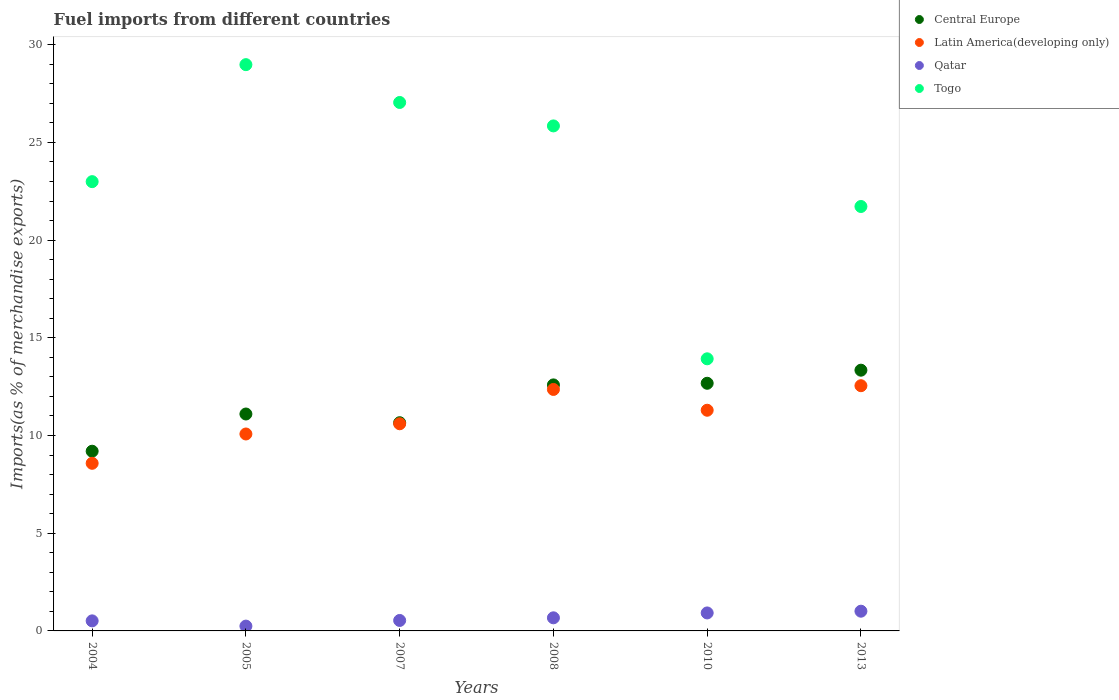How many different coloured dotlines are there?
Your answer should be very brief. 4. Is the number of dotlines equal to the number of legend labels?
Provide a succinct answer. Yes. What is the percentage of imports to different countries in Qatar in 2008?
Ensure brevity in your answer.  0.67. Across all years, what is the maximum percentage of imports to different countries in Qatar?
Make the answer very short. 1.01. Across all years, what is the minimum percentage of imports to different countries in Central Europe?
Provide a short and direct response. 9.2. In which year was the percentage of imports to different countries in Central Europe maximum?
Your answer should be very brief. 2013. What is the total percentage of imports to different countries in Togo in the graph?
Provide a succinct answer. 140.51. What is the difference between the percentage of imports to different countries in Central Europe in 2008 and that in 2013?
Your response must be concise. -0.75. What is the difference between the percentage of imports to different countries in Qatar in 2004 and the percentage of imports to different countries in Latin America(developing only) in 2008?
Give a very brief answer. -11.84. What is the average percentage of imports to different countries in Qatar per year?
Make the answer very short. 0.65. In the year 2010, what is the difference between the percentage of imports to different countries in Qatar and percentage of imports to different countries in Togo?
Provide a succinct answer. -13.01. In how many years, is the percentage of imports to different countries in Central Europe greater than 25 %?
Keep it short and to the point. 0. What is the ratio of the percentage of imports to different countries in Qatar in 2004 to that in 2013?
Keep it short and to the point. 0.51. Is the difference between the percentage of imports to different countries in Qatar in 2004 and 2013 greater than the difference between the percentage of imports to different countries in Togo in 2004 and 2013?
Provide a succinct answer. No. What is the difference between the highest and the second highest percentage of imports to different countries in Central Europe?
Provide a short and direct response. 0.67. What is the difference between the highest and the lowest percentage of imports to different countries in Togo?
Ensure brevity in your answer.  15.05. Is the sum of the percentage of imports to different countries in Togo in 2004 and 2007 greater than the maximum percentage of imports to different countries in Central Europe across all years?
Give a very brief answer. Yes. Is it the case that in every year, the sum of the percentage of imports to different countries in Central Europe and percentage of imports to different countries in Latin America(developing only)  is greater than the percentage of imports to different countries in Togo?
Ensure brevity in your answer.  No. Does the percentage of imports to different countries in Latin America(developing only) monotonically increase over the years?
Make the answer very short. No. Is the percentage of imports to different countries in Togo strictly greater than the percentage of imports to different countries in Latin America(developing only) over the years?
Ensure brevity in your answer.  Yes. Is the percentage of imports to different countries in Qatar strictly less than the percentage of imports to different countries in Latin America(developing only) over the years?
Your answer should be very brief. Yes. How many years are there in the graph?
Offer a very short reply. 6. What is the difference between two consecutive major ticks on the Y-axis?
Offer a terse response. 5. Does the graph contain grids?
Give a very brief answer. No. How many legend labels are there?
Provide a succinct answer. 4. What is the title of the graph?
Keep it short and to the point. Fuel imports from different countries. Does "Macao" appear as one of the legend labels in the graph?
Your answer should be compact. No. What is the label or title of the Y-axis?
Make the answer very short. Imports(as % of merchandise exports). What is the Imports(as % of merchandise exports) in Central Europe in 2004?
Offer a terse response. 9.2. What is the Imports(as % of merchandise exports) of Latin America(developing only) in 2004?
Your response must be concise. 8.58. What is the Imports(as % of merchandise exports) of Qatar in 2004?
Ensure brevity in your answer.  0.51. What is the Imports(as % of merchandise exports) in Togo in 2004?
Keep it short and to the point. 22.99. What is the Imports(as % of merchandise exports) of Central Europe in 2005?
Provide a short and direct response. 11.1. What is the Imports(as % of merchandise exports) in Latin America(developing only) in 2005?
Offer a terse response. 10.08. What is the Imports(as % of merchandise exports) in Qatar in 2005?
Give a very brief answer. 0.25. What is the Imports(as % of merchandise exports) of Togo in 2005?
Offer a very short reply. 28.98. What is the Imports(as % of merchandise exports) in Central Europe in 2007?
Make the answer very short. 10.66. What is the Imports(as % of merchandise exports) in Latin America(developing only) in 2007?
Offer a terse response. 10.6. What is the Imports(as % of merchandise exports) of Qatar in 2007?
Ensure brevity in your answer.  0.54. What is the Imports(as % of merchandise exports) of Togo in 2007?
Keep it short and to the point. 27.04. What is the Imports(as % of merchandise exports) in Central Europe in 2008?
Ensure brevity in your answer.  12.59. What is the Imports(as % of merchandise exports) in Latin America(developing only) in 2008?
Make the answer very short. 12.36. What is the Imports(as % of merchandise exports) in Qatar in 2008?
Make the answer very short. 0.67. What is the Imports(as % of merchandise exports) in Togo in 2008?
Offer a very short reply. 25.85. What is the Imports(as % of merchandise exports) in Central Europe in 2010?
Make the answer very short. 12.67. What is the Imports(as % of merchandise exports) in Latin America(developing only) in 2010?
Provide a succinct answer. 11.29. What is the Imports(as % of merchandise exports) of Qatar in 2010?
Keep it short and to the point. 0.92. What is the Imports(as % of merchandise exports) in Togo in 2010?
Your answer should be very brief. 13.93. What is the Imports(as % of merchandise exports) of Central Europe in 2013?
Your answer should be very brief. 13.34. What is the Imports(as % of merchandise exports) in Latin America(developing only) in 2013?
Offer a terse response. 12.55. What is the Imports(as % of merchandise exports) in Qatar in 2013?
Offer a terse response. 1.01. What is the Imports(as % of merchandise exports) of Togo in 2013?
Make the answer very short. 21.72. Across all years, what is the maximum Imports(as % of merchandise exports) of Central Europe?
Your response must be concise. 13.34. Across all years, what is the maximum Imports(as % of merchandise exports) in Latin America(developing only)?
Provide a succinct answer. 12.55. Across all years, what is the maximum Imports(as % of merchandise exports) in Qatar?
Ensure brevity in your answer.  1.01. Across all years, what is the maximum Imports(as % of merchandise exports) in Togo?
Your answer should be very brief. 28.98. Across all years, what is the minimum Imports(as % of merchandise exports) of Central Europe?
Provide a succinct answer. 9.2. Across all years, what is the minimum Imports(as % of merchandise exports) of Latin America(developing only)?
Make the answer very short. 8.58. Across all years, what is the minimum Imports(as % of merchandise exports) in Qatar?
Offer a terse response. 0.25. Across all years, what is the minimum Imports(as % of merchandise exports) of Togo?
Keep it short and to the point. 13.93. What is the total Imports(as % of merchandise exports) of Central Europe in the graph?
Provide a short and direct response. 69.56. What is the total Imports(as % of merchandise exports) of Latin America(developing only) in the graph?
Your answer should be compact. 65.46. What is the total Imports(as % of merchandise exports) of Qatar in the graph?
Make the answer very short. 3.9. What is the total Imports(as % of merchandise exports) in Togo in the graph?
Ensure brevity in your answer.  140.51. What is the difference between the Imports(as % of merchandise exports) of Central Europe in 2004 and that in 2005?
Offer a terse response. -1.9. What is the difference between the Imports(as % of merchandise exports) in Latin America(developing only) in 2004 and that in 2005?
Your answer should be very brief. -1.5. What is the difference between the Imports(as % of merchandise exports) of Qatar in 2004 and that in 2005?
Your response must be concise. 0.27. What is the difference between the Imports(as % of merchandise exports) of Togo in 2004 and that in 2005?
Your answer should be compact. -5.99. What is the difference between the Imports(as % of merchandise exports) of Central Europe in 2004 and that in 2007?
Make the answer very short. -1.46. What is the difference between the Imports(as % of merchandise exports) in Latin America(developing only) in 2004 and that in 2007?
Offer a terse response. -2.02. What is the difference between the Imports(as % of merchandise exports) in Qatar in 2004 and that in 2007?
Ensure brevity in your answer.  -0.02. What is the difference between the Imports(as % of merchandise exports) of Togo in 2004 and that in 2007?
Ensure brevity in your answer.  -4.05. What is the difference between the Imports(as % of merchandise exports) of Central Europe in 2004 and that in 2008?
Keep it short and to the point. -3.39. What is the difference between the Imports(as % of merchandise exports) of Latin America(developing only) in 2004 and that in 2008?
Offer a very short reply. -3.78. What is the difference between the Imports(as % of merchandise exports) in Qatar in 2004 and that in 2008?
Your response must be concise. -0.16. What is the difference between the Imports(as % of merchandise exports) in Togo in 2004 and that in 2008?
Your answer should be very brief. -2.85. What is the difference between the Imports(as % of merchandise exports) of Central Europe in 2004 and that in 2010?
Keep it short and to the point. -3.48. What is the difference between the Imports(as % of merchandise exports) of Latin America(developing only) in 2004 and that in 2010?
Provide a short and direct response. -2.72. What is the difference between the Imports(as % of merchandise exports) in Qatar in 2004 and that in 2010?
Make the answer very short. -0.41. What is the difference between the Imports(as % of merchandise exports) in Togo in 2004 and that in 2010?
Offer a terse response. 9.07. What is the difference between the Imports(as % of merchandise exports) in Central Europe in 2004 and that in 2013?
Ensure brevity in your answer.  -4.15. What is the difference between the Imports(as % of merchandise exports) in Latin America(developing only) in 2004 and that in 2013?
Offer a very short reply. -3.97. What is the difference between the Imports(as % of merchandise exports) in Qatar in 2004 and that in 2013?
Provide a succinct answer. -0.49. What is the difference between the Imports(as % of merchandise exports) of Togo in 2004 and that in 2013?
Give a very brief answer. 1.27. What is the difference between the Imports(as % of merchandise exports) of Central Europe in 2005 and that in 2007?
Make the answer very short. 0.45. What is the difference between the Imports(as % of merchandise exports) in Latin America(developing only) in 2005 and that in 2007?
Ensure brevity in your answer.  -0.52. What is the difference between the Imports(as % of merchandise exports) in Qatar in 2005 and that in 2007?
Ensure brevity in your answer.  -0.29. What is the difference between the Imports(as % of merchandise exports) of Togo in 2005 and that in 2007?
Make the answer very short. 1.94. What is the difference between the Imports(as % of merchandise exports) in Central Europe in 2005 and that in 2008?
Provide a succinct answer. -1.49. What is the difference between the Imports(as % of merchandise exports) of Latin America(developing only) in 2005 and that in 2008?
Ensure brevity in your answer.  -2.28. What is the difference between the Imports(as % of merchandise exports) of Qatar in 2005 and that in 2008?
Offer a very short reply. -0.42. What is the difference between the Imports(as % of merchandise exports) of Togo in 2005 and that in 2008?
Provide a short and direct response. 3.14. What is the difference between the Imports(as % of merchandise exports) of Central Europe in 2005 and that in 2010?
Ensure brevity in your answer.  -1.57. What is the difference between the Imports(as % of merchandise exports) of Latin America(developing only) in 2005 and that in 2010?
Your answer should be very brief. -1.22. What is the difference between the Imports(as % of merchandise exports) of Qatar in 2005 and that in 2010?
Ensure brevity in your answer.  -0.67. What is the difference between the Imports(as % of merchandise exports) of Togo in 2005 and that in 2010?
Provide a succinct answer. 15.05. What is the difference between the Imports(as % of merchandise exports) of Central Europe in 2005 and that in 2013?
Provide a succinct answer. -2.24. What is the difference between the Imports(as % of merchandise exports) of Latin America(developing only) in 2005 and that in 2013?
Provide a short and direct response. -2.47. What is the difference between the Imports(as % of merchandise exports) of Qatar in 2005 and that in 2013?
Ensure brevity in your answer.  -0.76. What is the difference between the Imports(as % of merchandise exports) of Togo in 2005 and that in 2013?
Offer a terse response. 7.26. What is the difference between the Imports(as % of merchandise exports) of Central Europe in 2007 and that in 2008?
Your answer should be very brief. -1.93. What is the difference between the Imports(as % of merchandise exports) of Latin America(developing only) in 2007 and that in 2008?
Provide a short and direct response. -1.76. What is the difference between the Imports(as % of merchandise exports) in Qatar in 2007 and that in 2008?
Your answer should be compact. -0.14. What is the difference between the Imports(as % of merchandise exports) in Togo in 2007 and that in 2008?
Ensure brevity in your answer.  1.2. What is the difference between the Imports(as % of merchandise exports) in Central Europe in 2007 and that in 2010?
Your answer should be very brief. -2.02. What is the difference between the Imports(as % of merchandise exports) of Latin America(developing only) in 2007 and that in 2010?
Ensure brevity in your answer.  -0.69. What is the difference between the Imports(as % of merchandise exports) in Qatar in 2007 and that in 2010?
Keep it short and to the point. -0.38. What is the difference between the Imports(as % of merchandise exports) in Togo in 2007 and that in 2010?
Your response must be concise. 13.12. What is the difference between the Imports(as % of merchandise exports) of Central Europe in 2007 and that in 2013?
Provide a succinct answer. -2.69. What is the difference between the Imports(as % of merchandise exports) in Latin America(developing only) in 2007 and that in 2013?
Offer a very short reply. -1.95. What is the difference between the Imports(as % of merchandise exports) of Qatar in 2007 and that in 2013?
Give a very brief answer. -0.47. What is the difference between the Imports(as % of merchandise exports) in Togo in 2007 and that in 2013?
Provide a succinct answer. 5.32. What is the difference between the Imports(as % of merchandise exports) in Central Europe in 2008 and that in 2010?
Offer a terse response. -0.08. What is the difference between the Imports(as % of merchandise exports) of Latin America(developing only) in 2008 and that in 2010?
Give a very brief answer. 1.06. What is the difference between the Imports(as % of merchandise exports) of Qatar in 2008 and that in 2010?
Keep it short and to the point. -0.25. What is the difference between the Imports(as % of merchandise exports) in Togo in 2008 and that in 2010?
Offer a very short reply. 11.92. What is the difference between the Imports(as % of merchandise exports) of Central Europe in 2008 and that in 2013?
Offer a very short reply. -0.75. What is the difference between the Imports(as % of merchandise exports) in Latin America(developing only) in 2008 and that in 2013?
Give a very brief answer. -0.19. What is the difference between the Imports(as % of merchandise exports) in Qatar in 2008 and that in 2013?
Make the answer very short. -0.34. What is the difference between the Imports(as % of merchandise exports) of Togo in 2008 and that in 2013?
Your answer should be very brief. 4.12. What is the difference between the Imports(as % of merchandise exports) in Central Europe in 2010 and that in 2013?
Give a very brief answer. -0.67. What is the difference between the Imports(as % of merchandise exports) of Latin America(developing only) in 2010 and that in 2013?
Keep it short and to the point. -1.26. What is the difference between the Imports(as % of merchandise exports) in Qatar in 2010 and that in 2013?
Provide a short and direct response. -0.09. What is the difference between the Imports(as % of merchandise exports) in Togo in 2010 and that in 2013?
Give a very brief answer. -7.8. What is the difference between the Imports(as % of merchandise exports) in Central Europe in 2004 and the Imports(as % of merchandise exports) in Latin America(developing only) in 2005?
Offer a very short reply. -0.88. What is the difference between the Imports(as % of merchandise exports) of Central Europe in 2004 and the Imports(as % of merchandise exports) of Qatar in 2005?
Your answer should be compact. 8.95. What is the difference between the Imports(as % of merchandise exports) of Central Europe in 2004 and the Imports(as % of merchandise exports) of Togo in 2005?
Provide a short and direct response. -19.78. What is the difference between the Imports(as % of merchandise exports) of Latin America(developing only) in 2004 and the Imports(as % of merchandise exports) of Qatar in 2005?
Offer a very short reply. 8.33. What is the difference between the Imports(as % of merchandise exports) in Latin America(developing only) in 2004 and the Imports(as % of merchandise exports) in Togo in 2005?
Your answer should be very brief. -20.4. What is the difference between the Imports(as % of merchandise exports) in Qatar in 2004 and the Imports(as % of merchandise exports) in Togo in 2005?
Your response must be concise. -28.47. What is the difference between the Imports(as % of merchandise exports) of Central Europe in 2004 and the Imports(as % of merchandise exports) of Latin America(developing only) in 2007?
Ensure brevity in your answer.  -1.41. What is the difference between the Imports(as % of merchandise exports) in Central Europe in 2004 and the Imports(as % of merchandise exports) in Qatar in 2007?
Give a very brief answer. 8.66. What is the difference between the Imports(as % of merchandise exports) of Central Europe in 2004 and the Imports(as % of merchandise exports) of Togo in 2007?
Provide a short and direct response. -17.85. What is the difference between the Imports(as % of merchandise exports) of Latin America(developing only) in 2004 and the Imports(as % of merchandise exports) of Qatar in 2007?
Give a very brief answer. 8.04. What is the difference between the Imports(as % of merchandise exports) of Latin America(developing only) in 2004 and the Imports(as % of merchandise exports) of Togo in 2007?
Offer a very short reply. -18.47. What is the difference between the Imports(as % of merchandise exports) in Qatar in 2004 and the Imports(as % of merchandise exports) in Togo in 2007?
Give a very brief answer. -26.53. What is the difference between the Imports(as % of merchandise exports) in Central Europe in 2004 and the Imports(as % of merchandise exports) in Latin America(developing only) in 2008?
Provide a short and direct response. -3.16. What is the difference between the Imports(as % of merchandise exports) in Central Europe in 2004 and the Imports(as % of merchandise exports) in Qatar in 2008?
Ensure brevity in your answer.  8.53. What is the difference between the Imports(as % of merchandise exports) of Central Europe in 2004 and the Imports(as % of merchandise exports) of Togo in 2008?
Give a very brief answer. -16.65. What is the difference between the Imports(as % of merchandise exports) of Latin America(developing only) in 2004 and the Imports(as % of merchandise exports) of Qatar in 2008?
Offer a terse response. 7.91. What is the difference between the Imports(as % of merchandise exports) of Latin America(developing only) in 2004 and the Imports(as % of merchandise exports) of Togo in 2008?
Ensure brevity in your answer.  -17.27. What is the difference between the Imports(as % of merchandise exports) of Qatar in 2004 and the Imports(as % of merchandise exports) of Togo in 2008?
Provide a short and direct response. -25.33. What is the difference between the Imports(as % of merchandise exports) of Central Europe in 2004 and the Imports(as % of merchandise exports) of Latin America(developing only) in 2010?
Provide a short and direct response. -2.1. What is the difference between the Imports(as % of merchandise exports) in Central Europe in 2004 and the Imports(as % of merchandise exports) in Qatar in 2010?
Make the answer very short. 8.28. What is the difference between the Imports(as % of merchandise exports) of Central Europe in 2004 and the Imports(as % of merchandise exports) of Togo in 2010?
Offer a very short reply. -4.73. What is the difference between the Imports(as % of merchandise exports) in Latin America(developing only) in 2004 and the Imports(as % of merchandise exports) in Qatar in 2010?
Your answer should be compact. 7.66. What is the difference between the Imports(as % of merchandise exports) in Latin America(developing only) in 2004 and the Imports(as % of merchandise exports) in Togo in 2010?
Offer a terse response. -5.35. What is the difference between the Imports(as % of merchandise exports) of Qatar in 2004 and the Imports(as % of merchandise exports) of Togo in 2010?
Give a very brief answer. -13.41. What is the difference between the Imports(as % of merchandise exports) of Central Europe in 2004 and the Imports(as % of merchandise exports) of Latin America(developing only) in 2013?
Offer a very short reply. -3.35. What is the difference between the Imports(as % of merchandise exports) of Central Europe in 2004 and the Imports(as % of merchandise exports) of Qatar in 2013?
Keep it short and to the point. 8.19. What is the difference between the Imports(as % of merchandise exports) in Central Europe in 2004 and the Imports(as % of merchandise exports) in Togo in 2013?
Provide a succinct answer. -12.52. What is the difference between the Imports(as % of merchandise exports) in Latin America(developing only) in 2004 and the Imports(as % of merchandise exports) in Qatar in 2013?
Offer a very short reply. 7.57. What is the difference between the Imports(as % of merchandise exports) of Latin America(developing only) in 2004 and the Imports(as % of merchandise exports) of Togo in 2013?
Offer a terse response. -13.14. What is the difference between the Imports(as % of merchandise exports) of Qatar in 2004 and the Imports(as % of merchandise exports) of Togo in 2013?
Make the answer very short. -21.21. What is the difference between the Imports(as % of merchandise exports) in Central Europe in 2005 and the Imports(as % of merchandise exports) in Latin America(developing only) in 2007?
Your answer should be compact. 0.5. What is the difference between the Imports(as % of merchandise exports) of Central Europe in 2005 and the Imports(as % of merchandise exports) of Qatar in 2007?
Your response must be concise. 10.57. What is the difference between the Imports(as % of merchandise exports) of Central Europe in 2005 and the Imports(as % of merchandise exports) of Togo in 2007?
Provide a succinct answer. -15.94. What is the difference between the Imports(as % of merchandise exports) in Latin America(developing only) in 2005 and the Imports(as % of merchandise exports) in Qatar in 2007?
Offer a terse response. 9.54. What is the difference between the Imports(as % of merchandise exports) of Latin America(developing only) in 2005 and the Imports(as % of merchandise exports) of Togo in 2007?
Your response must be concise. -16.97. What is the difference between the Imports(as % of merchandise exports) in Qatar in 2005 and the Imports(as % of merchandise exports) in Togo in 2007?
Offer a very short reply. -26.8. What is the difference between the Imports(as % of merchandise exports) in Central Europe in 2005 and the Imports(as % of merchandise exports) in Latin America(developing only) in 2008?
Provide a succinct answer. -1.26. What is the difference between the Imports(as % of merchandise exports) in Central Europe in 2005 and the Imports(as % of merchandise exports) in Qatar in 2008?
Your answer should be compact. 10.43. What is the difference between the Imports(as % of merchandise exports) in Central Europe in 2005 and the Imports(as % of merchandise exports) in Togo in 2008?
Make the answer very short. -14.74. What is the difference between the Imports(as % of merchandise exports) in Latin America(developing only) in 2005 and the Imports(as % of merchandise exports) in Qatar in 2008?
Ensure brevity in your answer.  9.41. What is the difference between the Imports(as % of merchandise exports) in Latin America(developing only) in 2005 and the Imports(as % of merchandise exports) in Togo in 2008?
Your answer should be very brief. -15.77. What is the difference between the Imports(as % of merchandise exports) of Qatar in 2005 and the Imports(as % of merchandise exports) of Togo in 2008?
Make the answer very short. -25.6. What is the difference between the Imports(as % of merchandise exports) in Central Europe in 2005 and the Imports(as % of merchandise exports) in Latin America(developing only) in 2010?
Give a very brief answer. -0.19. What is the difference between the Imports(as % of merchandise exports) of Central Europe in 2005 and the Imports(as % of merchandise exports) of Qatar in 2010?
Give a very brief answer. 10.18. What is the difference between the Imports(as % of merchandise exports) in Central Europe in 2005 and the Imports(as % of merchandise exports) in Togo in 2010?
Your response must be concise. -2.82. What is the difference between the Imports(as % of merchandise exports) in Latin America(developing only) in 2005 and the Imports(as % of merchandise exports) in Qatar in 2010?
Your response must be concise. 9.16. What is the difference between the Imports(as % of merchandise exports) in Latin America(developing only) in 2005 and the Imports(as % of merchandise exports) in Togo in 2010?
Make the answer very short. -3.85. What is the difference between the Imports(as % of merchandise exports) of Qatar in 2005 and the Imports(as % of merchandise exports) of Togo in 2010?
Your answer should be compact. -13.68. What is the difference between the Imports(as % of merchandise exports) in Central Europe in 2005 and the Imports(as % of merchandise exports) in Latin America(developing only) in 2013?
Provide a short and direct response. -1.45. What is the difference between the Imports(as % of merchandise exports) of Central Europe in 2005 and the Imports(as % of merchandise exports) of Qatar in 2013?
Ensure brevity in your answer.  10.09. What is the difference between the Imports(as % of merchandise exports) of Central Europe in 2005 and the Imports(as % of merchandise exports) of Togo in 2013?
Offer a terse response. -10.62. What is the difference between the Imports(as % of merchandise exports) in Latin America(developing only) in 2005 and the Imports(as % of merchandise exports) in Qatar in 2013?
Make the answer very short. 9.07. What is the difference between the Imports(as % of merchandise exports) of Latin America(developing only) in 2005 and the Imports(as % of merchandise exports) of Togo in 2013?
Keep it short and to the point. -11.64. What is the difference between the Imports(as % of merchandise exports) of Qatar in 2005 and the Imports(as % of merchandise exports) of Togo in 2013?
Provide a succinct answer. -21.47. What is the difference between the Imports(as % of merchandise exports) of Central Europe in 2007 and the Imports(as % of merchandise exports) of Latin America(developing only) in 2008?
Offer a very short reply. -1.7. What is the difference between the Imports(as % of merchandise exports) in Central Europe in 2007 and the Imports(as % of merchandise exports) in Qatar in 2008?
Provide a short and direct response. 9.99. What is the difference between the Imports(as % of merchandise exports) in Central Europe in 2007 and the Imports(as % of merchandise exports) in Togo in 2008?
Offer a terse response. -15.19. What is the difference between the Imports(as % of merchandise exports) of Latin America(developing only) in 2007 and the Imports(as % of merchandise exports) of Qatar in 2008?
Ensure brevity in your answer.  9.93. What is the difference between the Imports(as % of merchandise exports) of Latin America(developing only) in 2007 and the Imports(as % of merchandise exports) of Togo in 2008?
Ensure brevity in your answer.  -15.24. What is the difference between the Imports(as % of merchandise exports) in Qatar in 2007 and the Imports(as % of merchandise exports) in Togo in 2008?
Offer a very short reply. -25.31. What is the difference between the Imports(as % of merchandise exports) in Central Europe in 2007 and the Imports(as % of merchandise exports) in Latin America(developing only) in 2010?
Provide a short and direct response. -0.64. What is the difference between the Imports(as % of merchandise exports) in Central Europe in 2007 and the Imports(as % of merchandise exports) in Qatar in 2010?
Your answer should be compact. 9.74. What is the difference between the Imports(as % of merchandise exports) of Central Europe in 2007 and the Imports(as % of merchandise exports) of Togo in 2010?
Your answer should be very brief. -3.27. What is the difference between the Imports(as % of merchandise exports) in Latin America(developing only) in 2007 and the Imports(as % of merchandise exports) in Qatar in 2010?
Keep it short and to the point. 9.68. What is the difference between the Imports(as % of merchandise exports) of Latin America(developing only) in 2007 and the Imports(as % of merchandise exports) of Togo in 2010?
Ensure brevity in your answer.  -3.32. What is the difference between the Imports(as % of merchandise exports) in Qatar in 2007 and the Imports(as % of merchandise exports) in Togo in 2010?
Provide a short and direct response. -13.39. What is the difference between the Imports(as % of merchandise exports) in Central Europe in 2007 and the Imports(as % of merchandise exports) in Latin America(developing only) in 2013?
Make the answer very short. -1.89. What is the difference between the Imports(as % of merchandise exports) of Central Europe in 2007 and the Imports(as % of merchandise exports) of Qatar in 2013?
Make the answer very short. 9.65. What is the difference between the Imports(as % of merchandise exports) in Central Europe in 2007 and the Imports(as % of merchandise exports) in Togo in 2013?
Keep it short and to the point. -11.07. What is the difference between the Imports(as % of merchandise exports) in Latin America(developing only) in 2007 and the Imports(as % of merchandise exports) in Qatar in 2013?
Ensure brevity in your answer.  9.59. What is the difference between the Imports(as % of merchandise exports) of Latin America(developing only) in 2007 and the Imports(as % of merchandise exports) of Togo in 2013?
Give a very brief answer. -11.12. What is the difference between the Imports(as % of merchandise exports) in Qatar in 2007 and the Imports(as % of merchandise exports) in Togo in 2013?
Offer a terse response. -21.19. What is the difference between the Imports(as % of merchandise exports) of Central Europe in 2008 and the Imports(as % of merchandise exports) of Latin America(developing only) in 2010?
Provide a succinct answer. 1.3. What is the difference between the Imports(as % of merchandise exports) of Central Europe in 2008 and the Imports(as % of merchandise exports) of Qatar in 2010?
Offer a very short reply. 11.67. What is the difference between the Imports(as % of merchandise exports) in Central Europe in 2008 and the Imports(as % of merchandise exports) in Togo in 2010?
Provide a short and direct response. -1.34. What is the difference between the Imports(as % of merchandise exports) in Latin America(developing only) in 2008 and the Imports(as % of merchandise exports) in Qatar in 2010?
Provide a succinct answer. 11.44. What is the difference between the Imports(as % of merchandise exports) of Latin America(developing only) in 2008 and the Imports(as % of merchandise exports) of Togo in 2010?
Your response must be concise. -1.57. What is the difference between the Imports(as % of merchandise exports) of Qatar in 2008 and the Imports(as % of merchandise exports) of Togo in 2010?
Provide a short and direct response. -13.26. What is the difference between the Imports(as % of merchandise exports) in Central Europe in 2008 and the Imports(as % of merchandise exports) in Latin America(developing only) in 2013?
Your response must be concise. 0.04. What is the difference between the Imports(as % of merchandise exports) in Central Europe in 2008 and the Imports(as % of merchandise exports) in Qatar in 2013?
Keep it short and to the point. 11.58. What is the difference between the Imports(as % of merchandise exports) of Central Europe in 2008 and the Imports(as % of merchandise exports) of Togo in 2013?
Provide a short and direct response. -9.13. What is the difference between the Imports(as % of merchandise exports) in Latin America(developing only) in 2008 and the Imports(as % of merchandise exports) in Qatar in 2013?
Provide a succinct answer. 11.35. What is the difference between the Imports(as % of merchandise exports) of Latin America(developing only) in 2008 and the Imports(as % of merchandise exports) of Togo in 2013?
Offer a terse response. -9.36. What is the difference between the Imports(as % of merchandise exports) of Qatar in 2008 and the Imports(as % of merchandise exports) of Togo in 2013?
Offer a terse response. -21.05. What is the difference between the Imports(as % of merchandise exports) of Central Europe in 2010 and the Imports(as % of merchandise exports) of Latin America(developing only) in 2013?
Provide a short and direct response. 0.12. What is the difference between the Imports(as % of merchandise exports) of Central Europe in 2010 and the Imports(as % of merchandise exports) of Qatar in 2013?
Your answer should be very brief. 11.66. What is the difference between the Imports(as % of merchandise exports) in Central Europe in 2010 and the Imports(as % of merchandise exports) in Togo in 2013?
Provide a short and direct response. -9.05. What is the difference between the Imports(as % of merchandise exports) in Latin America(developing only) in 2010 and the Imports(as % of merchandise exports) in Qatar in 2013?
Offer a terse response. 10.28. What is the difference between the Imports(as % of merchandise exports) of Latin America(developing only) in 2010 and the Imports(as % of merchandise exports) of Togo in 2013?
Provide a short and direct response. -10.43. What is the difference between the Imports(as % of merchandise exports) of Qatar in 2010 and the Imports(as % of merchandise exports) of Togo in 2013?
Your answer should be compact. -20.8. What is the average Imports(as % of merchandise exports) in Central Europe per year?
Provide a short and direct response. 11.59. What is the average Imports(as % of merchandise exports) of Latin America(developing only) per year?
Give a very brief answer. 10.91. What is the average Imports(as % of merchandise exports) of Qatar per year?
Offer a very short reply. 0.65. What is the average Imports(as % of merchandise exports) in Togo per year?
Offer a very short reply. 23.42. In the year 2004, what is the difference between the Imports(as % of merchandise exports) in Central Europe and Imports(as % of merchandise exports) in Latin America(developing only)?
Ensure brevity in your answer.  0.62. In the year 2004, what is the difference between the Imports(as % of merchandise exports) of Central Europe and Imports(as % of merchandise exports) of Qatar?
Give a very brief answer. 8.68. In the year 2004, what is the difference between the Imports(as % of merchandise exports) of Central Europe and Imports(as % of merchandise exports) of Togo?
Provide a succinct answer. -13.8. In the year 2004, what is the difference between the Imports(as % of merchandise exports) of Latin America(developing only) and Imports(as % of merchandise exports) of Qatar?
Your answer should be compact. 8.06. In the year 2004, what is the difference between the Imports(as % of merchandise exports) of Latin America(developing only) and Imports(as % of merchandise exports) of Togo?
Your answer should be very brief. -14.41. In the year 2004, what is the difference between the Imports(as % of merchandise exports) in Qatar and Imports(as % of merchandise exports) in Togo?
Your response must be concise. -22.48. In the year 2005, what is the difference between the Imports(as % of merchandise exports) of Central Europe and Imports(as % of merchandise exports) of Latin America(developing only)?
Offer a terse response. 1.02. In the year 2005, what is the difference between the Imports(as % of merchandise exports) of Central Europe and Imports(as % of merchandise exports) of Qatar?
Your answer should be compact. 10.85. In the year 2005, what is the difference between the Imports(as % of merchandise exports) of Central Europe and Imports(as % of merchandise exports) of Togo?
Provide a succinct answer. -17.88. In the year 2005, what is the difference between the Imports(as % of merchandise exports) of Latin America(developing only) and Imports(as % of merchandise exports) of Qatar?
Provide a short and direct response. 9.83. In the year 2005, what is the difference between the Imports(as % of merchandise exports) in Latin America(developing only) and Imports(as % of merchandise exports) in Togo?
Keep it short and to the point. -18.9. In the year 2005, what is the difference between the Imports(as % of merchandise exports) in Qatar and Imports(as % of merchandise exports) in Togo?
Your answer should be compact. -28.73. In the year 2007, what is the difference between the Imports(as % of merchandise exports) in Central Europe and Imports(as % of merchandise exports) in Latin America(developing only)?
Your answer should be very brief. 0.05. In the year 2007, what is the difference between the Imports(as % of merchandise exports) in Central Europe and Imports(as % of merchandise exports) in Qatar?
Keep it short and to the point. 10.12. In the year 2007, what is the difference between the Imports(as % of merchandise exports) of Central Europe and Imports(as % of merchandise exports) of Togo?
Your answer should be very brief. -16.39. In the year 2007, what is the difference between the Imports(as % of merchandise exports) of Latin America(developing only) and Imports(as % of merchandise exports) of Qatar?
Ensure brevity in your answer.  10.07. In the year 2007, what is the difference between the Imports(as % of merchandise exports) of Latin America(developing only) and Imports(as % of merchandise exports) of Togo?
Provide a short and direct response. -16.44. In the year 2007, what is the difference between the Imports(as % of merchandise exports) in Qatar and Imports(as % of merchandise exports) in Togo?
Your response must be concise. -26.51. In the year 2008, what is the difference between the Imports(as % of merchandise exports) in Central Europe and Imports(as % of merchandise exports) in Latin America(developing only)?
Your response must be concise. 0.23. In the year 2008, what is the difference between the Imports(as % of merchandise exports) of Central Europe and Imports(as % of merchandise exports) of Qatar?
Ensure brevity in your answer.  11.92. In the year 2008, what is the difference between the Imports(as % of merchandise exports) of Central Europe and Imports(as % of merchandise exports) of Togo?
Give a very brief answer. -13.25. In the year 2008, what is the difference between the Imports(as % of merchandise exports) in Latin America(developing only) and Imports(as % of merchandise exports) in Qatar?
Provide a short and direct response. 11.69. In the year 2008, what is the difference between the Imports(as % of merchandise exports) in Latin America(developing only) and Imports(as % of merchandise exports) in Togo?
Provide a succinct answer. -13.49. In the year 2008, what is the difference between the Imports(as % of merchandise exports) in Qatar and Imports(as % of merchandise exports) in Togo?
Ensure brevity in your answer.  -25.17. In the year 2010, what is the difference between the Imports(as % of merchandise exports) in Central Europe and Imports(as % of merchandise exports) in Latin America(developing only)?
Give a very brief answer. 1.38. In the year 2010, what is the difference between the Imports(as % of merchandise exports) in Central Europe and Imports(as % of merchandise exports) in Qatar?
Provide a short and direct response. 11.75. In the year 2010, what is the difference between the Imports(as % of merchandise exports) in Central Europe and Imports(as % of merchandise exports) in Togo?
Offer a terse response. -1.25. In the year 2010, what is the difference between the Imports(as % of merchandise exports) of Latin America(developing only) and Imports(as % of merchandise exports) of Qatar?
Give a very brief answer. 10.37. In the year 2010, what is the difference between the Imports(as % of merchandise exports) of Latin America(developing only) and Imports(as % of merchandise exports) of Togo?
Keep it short and to the point. -2.63. In the year 2010, what is the difference between the Imports(as % of merchandise exports) in Qatar and Imports(as % of merchandise exports) in Togo?
Offer a terse response. -13.01. In the year 2013, what is the difference between the Imports(as % of merchandise exports) of Central Europe and Imports(as % of merchandise exports) of Latin America(developing only)?
Your response must be concise. 0.79. In the year 2013, what is the difference between the Imports(as % of merchandise exports) of Central Europe and Imports(as % of merchandise exports) of Qatar?
Give a very brief answer. 12.33. In the year 2013, what is the difference between the Imports(as % of merchandise exports) in Central Europe and Imports(as % of merchandise exports) in Togo?
Your response must be concise. -8.38. In the year 2013, what is the difference between the Imports(as % of merchandise exports) of Latin America(developing only) and Imports(as % of merchandise exports) of Qatar?
Offer a very short reply. 11.54. In the year 2013, what is the difference between the Imports(as % of merchandise exports) of Latin America(developing only) and Imports(as % of merchandise exports) of Togo?
Keep it short and to the point. -9.17. In the year 2013, what is the difference between the Imports(as % of merchandise exports) in Qatar and Imports(as % of merchandise exports) in Togo?
Make the answer very short. -20.71. What is the ratio of the Imports(as % of merchandise exports) of Central Europe in 2004 to that in 2005?
Keep it short and to the point. 0.83. What is the ratio of the Imports(as % of merchandise exports) in Latin America(developing only) in 2004 to that in 2005?
Your answer should be compact. 0.85. What is the ratio of the Imports(as % of merchandise exports) of Qatar in 2004 to that in 2005?
Your answer should be very brief. 2.09. What is the ratio of the Imports(as % of merchandise exports) of Togo in 2004 to that in 2005?
Your response must be concise. 0.79. What is the ratio of the Imports(as % of merchandise exports) of Central Europe in 2004 to that in 2007?
Offer a terse response. 0.86. What is the ratio of the Imports(as % of merchandise exports) of Latin America(developing only) in 2004 to that in 2007?
Give a very brief answer. 0.81. What is the ratio of the Imports(as % of merchandise exports) of Qatar in 2004 to that in 2007?
Offer a very short reply. 0.96. What is the ratio of the Imports(as % of merchandise exports) of Togo in 2004 to that in 2007?
Your answer should be compact. 0.85. What is the ratio of the Imports(as % of merchandise exports) of Central Europe in 2004 to that in 2008?
Provide a short and direct response. 0.73. What is the ratio of the Imports(as % of merchandise exports) of Latin America(developing only) in 2004 to that in 2008?
Ensure brevity in your answer.  0.69. What is the ratio of the Imports(as % of merchandise exports) in Qatar in 2004 to that in 2008?
Your answer should be very brief. 0.77. What is the ratio of the Imports(as % of merchandise exports) in Togo in 2004 to that in 2008?
Your response must be concise. 0.89. What is the ratio of the Imports(as % of merchandise exports) in Central Europe in 2004 to that in 2010?
Ensure brevity in your answer.  0.73. What is the ratio of the Imports(as % of merchandise exports) in Latin America(developing only) in 2004 to that in 2010?
Keep it short and to the point. 0.76. What is the ratio of the Imports(as % of merchandise exports) of Qatar in 2004 to that in 2010?
Offer a very short reply. 0.56. What is the ratio of the Imports(as % of merchandise exports) in Togo in 2004 to that in 2010?
Your answer should be very brief. 1.65. What is the ratio of the Imports(as % of merchandise exports) of Central Europe in 2004 to that in 2013?
Your response must be concise. 0.69. What is the ratio of the Imports(as % of merchandise exports) in Latin America(developing only) in 2004 to that in 2013?
Make the answer very short. 0.68. What is the ratio of the Imports(as % of merchandise exports) of Qatar in 2004 to that in 2013?
Give a very brief answer. 0.51. What is the ratio of the Imports(as % of merchandise exports) of Togo in 2004 to that in 2013?
Provide a succinct answer. 1.06. What is the ratio of the Imports(as % of merchandise exports) of Central Europe in 2005 to that in 2007?
Give a very brief answer. 1.04. What is the ratio of the Imports(as % of merchandise exports) in Latin America(developing only) in 2005 to that in 2007?
Your answer should be compact. 0.95. What is the ratio of the Imports(as % of merchandise exports) in Qatar in 2005 to that in 2007?
Ensure brevity in your answer.  0.46. What is the ratio of the Imports(as % of merchandise exports) in Togo in 2005 to that in 2007?
Give a very brief answer. 1.07. What is the ratio of the Imports(as % of merchandise exports) in Central Europe in 2005 to that in 2008?
Keep it short and to the point. 0.88. What is the ratio of the Imports(as % of merchandise exports) of Latin America(developing only) in 2005 to that in 2008?
Offer a terse response. 0.82. What is the ratio of the Imports(as % of merchandise exports) of Qatar in 2005 to that in 2008?
Your answer should be compact. 0.37. What is the ratio of the Imports(as % of merchandise exports) of Togo in 2005 to that in 2008?
Provide a short and direct response. 1.12. What is the ratio of the Imports(as % of merchandise exports) in Central Europe in 2005 to that in 2010?
Offer a very short reply. 0.88. What is the ratio of the Imports(as % of merchandise exports) in Latin America(developing only) in 2005 to that in 2010?
Your answer should be very brief. 0.89. What is the ratio of the Imports(as % of merchandise exports) in Qatar in 2005 to that in 2010?
Your response must be concise. 0.27. What is the ratio of the Imports(as % of merchandise exports) in Togo in 2005 to that in 2010?
Your response must be concise. 2.08. What is the ratio of the Imports(as % of merchandise exports) in Central Europe in 2005 to that in 2013?
Provide a short and direct response. 0.83. What is the ratio of the Imports(as % of merchandise exports) in Latin America(developing only) in 2005 to that in 2013?
Offer a very short reply. 0.8. What is the ratio of the Imports(as % of merchandise exports) of Qatar in 2005 to that in 2013?
Provide a succinct answer. 0.24. What is the ratio of the Imports(as % of merchandise exports) in Togo in 2005 to that in 2013?
Your answer should be very brief. 1.33. What is the ratio of the Imports(as % of merchandise exports) of Central Europe in 2007 to that in 2008?
Offer a terse response. 0.85. What is the ratio of the Imports(as % of merchandise exports) of Latin America(developing only) in 2007 to that in 2008?
Give a very brief answer. 0.86. What is the ratio of the Imports(as % of merchandise exports) of Qatar in 2007 to that in 2008?
Offer a very short reply. 0.8. What is the ratio of the Imports(as % of merchandise exports) in Togo in 2007 to that in 2008?
Provide a short and direct response. 1.05. What is the ratio of the Imports(as % of merchandise exports) in Central Europe in 2007 to that in 2010?
Your response must be concise. 0.84. What is the ratio of the Imports(as % of merchandise exports) of Latin America(developing only) in 2007 to that in 2010?
Provide a short and direct response. 0.94. What is the ratio of the Imports(as % of merchandise exports) in Qatar in 2007 to that in 2010?
Provide a short and direct response. 0.58. What is the ratio of the Imports(as % of merchandise exports) of Togo in 2007 to that in 2010?
Provide a succinct answer. 1.94. What is the ratio of the Imports(as % of merchandise exports) of Central Europe in 2007 to that in 2013?
Your answer should be compact. 0.8. What is the ratio of the Imports(as % of merchandise exports) of Latin America(developing only) in 2007 to that in 2013?
Keep it short and to the point. 0.84. What is the ratio of the Imports(as % of merchandise exports) in Qatar in 2007 to that in 2013?
Your response must be concise. 0.53. What is the ratio of the Imports(as % of merchandise exports) of Togo in 2007 to that in 2013?
Provide a short and direct response. 1.25. What is the ratio of the Imports(as % of merchandise exports) of Latin America(developing only) in 2008 to that in 2010?
Your answer should be compact. 1.09. What is the ratio of the Imports(as % of merchandise exports) in Qatar in 2008 to that in 2010?
Your answer should be very brief. 0.73. What is the ratio of the Imports(as % of merchandise exports) of Togo in 2008 to that in 2010?
Offer a terse response. 1.86. What is the ratio of the Imports(as % of merchandise exports) of Central Europe in 2008 to that in 2013?
Give a very brief answer. 0.94. What is the ratio of the Imports(as % of merchandise exports) in Latin America(developing only) in 2008 to that in 2013?
Provide a short and direct response. 0.98. What is the ratio of the Imports(as % of merchandise exports) in Qatar in 2008 to that in 2013?
Give a very brief answer. 0.66. What is the ratio of the Imports(as % of merchandise exports) of Togo in 2008 to that in 2013?
Provide a succinct answer. 1.19. What is the ratio of the Imports(as % of merchandise exports) of Central Europe in 2010 to that in 2013?
Provide a succinct answer. 0.95. What is the ratio of the Imports(as % of merchandise exports) of Latin America(developing only) in 2010 to that in 2013?
Provide a succinct answer. 0.9. What is the ratio of the Imports(as % of merchandise exports) of Qatar in 2010 to that in 2013?
Ensure brevity in your answer.  0.91. What is the ratio of the Imports(as % of merchandise exports) in Togo in 2010 to that in 2013?
Make the answer very short. 0.64. What is the difference between the highest and the second highest Imports(as % of merchandise exports) in Central Europe?
Make the answer very short. 0.67. What is the difference between the highest and the second highest Imports(as % of merchandise exports) in Latin America(developing only)?
Your response must be concise. 0.19. What is the difference between the highest and the second highest Imports(as % of merchandise exports) of Qatar?
Keep it short and to the point. 0.09. What is the difference between the highest and the second highest Imports(as % of merchandise exports) of Togo?
Your answer should be very brief. 1.94. What is the difference between the highest and the lowest Imports(as % of merchandise exports) in Central Europe?
Provide a succinct answer. 4.15. What is the difference between the highest and the lowest Imports(as % of merchandise exports) in Latin America(developing only)?
Offer a terse response. 3.97. What is the difference between the highest and the lowest Imports(as % of merchandise exports) in Qatar?
Provide a short and direct response. 0.76. What is the difference between the highest and the lowest Imports(as % of merchandise exports) in Togo?
Your answer should be compact. 15.05. 